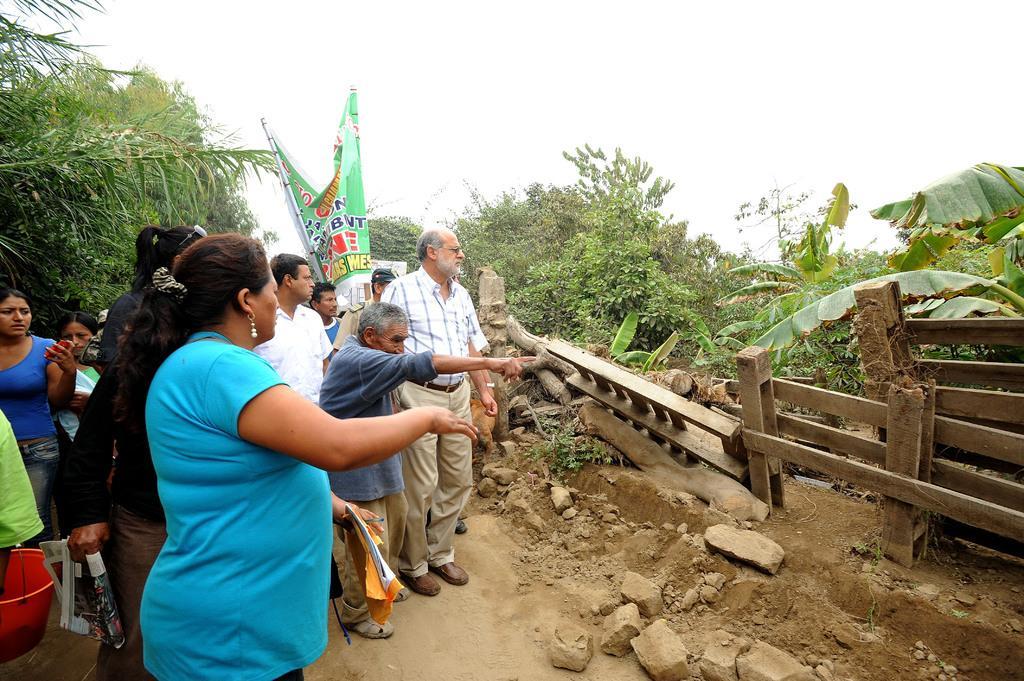How would you summarize this image in a sentence or two? In this image there are few persons standing on the land. Left side there is a bucket. A woman wearing a blue top is holding a book and a pen in her hand. Behind the persons there is a banner. Behind it there is a house. Right side there is fence on the land having few rocks. Background there are few plants and trees. Top of the image there is sky. 